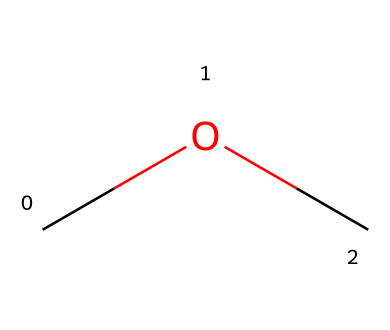What is the name of this chemical? The structure has a carbon atom bonded to oxygen and another carbon atom (COC), which identifies it as dimethyl ether.
Answer: dimethyl ether How many carbon atoms are in the molecule? The SMILES representation shows two carbon atoms (C) connected to the oxygen (O), making a total of two carbon atoms.
Answer: 2 What type of functional group is present in this chemical? The presence of the ether connection (C-O-C) indicates that this molecule contains an ether functional group.
Answer: ether What is the total number of hydrogen atoms in dimethyl ether? Each carbon (C) in dimethyl ether is bonded to three hydrogens (H) resulting in a total of 6 hydrogen atoms (3 for each C).
Answer: 6 How many single bonds are there in the structure? The structure contains a total of three single bonds: one between each carbon and the oxygen and two between the carbons and their hydrogens.
Answer: 3 Is dimethyl ether a polar molecule? The presence of oxygen creates a polar bond with the carbon atoms, thus making the molecule polar due to the different electronegativities.
Answer: yes 